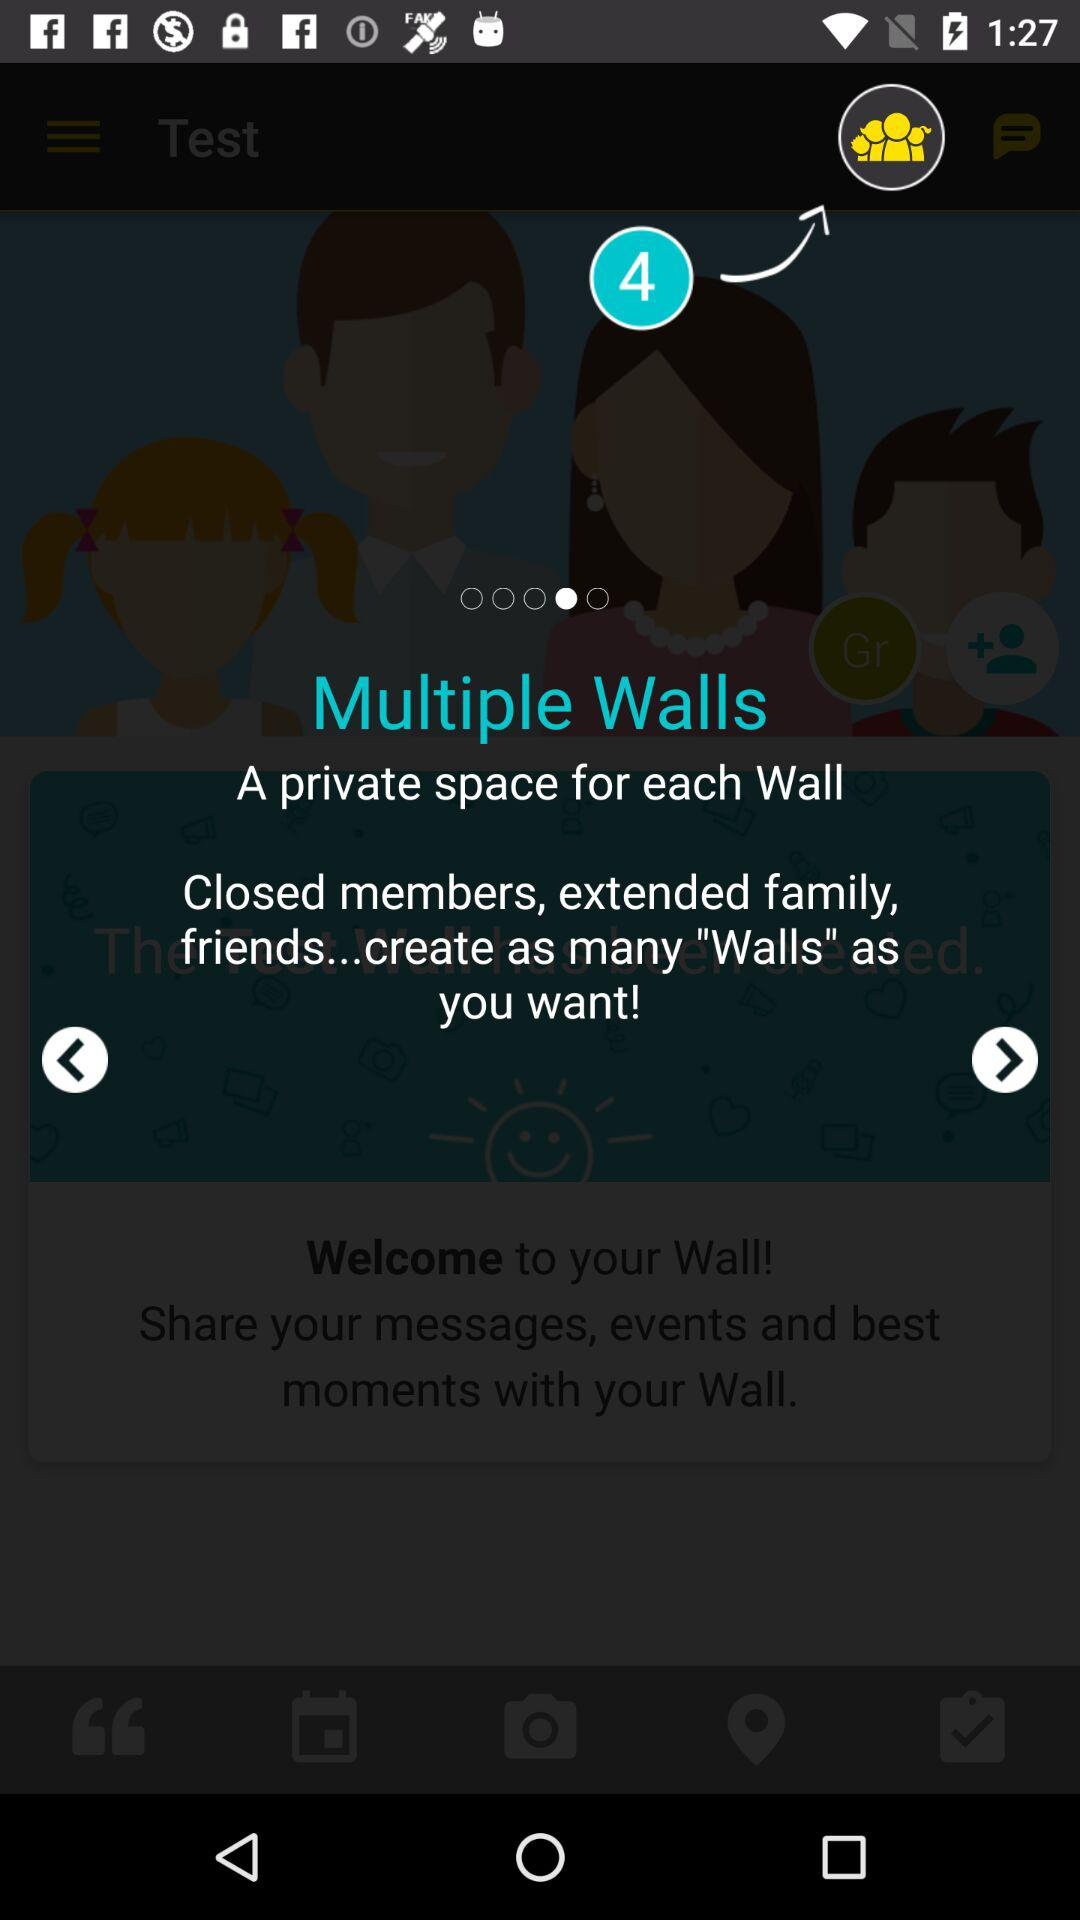How many members are there?
When the provided information is insufficient, respond with <no answer>. <no answer> 